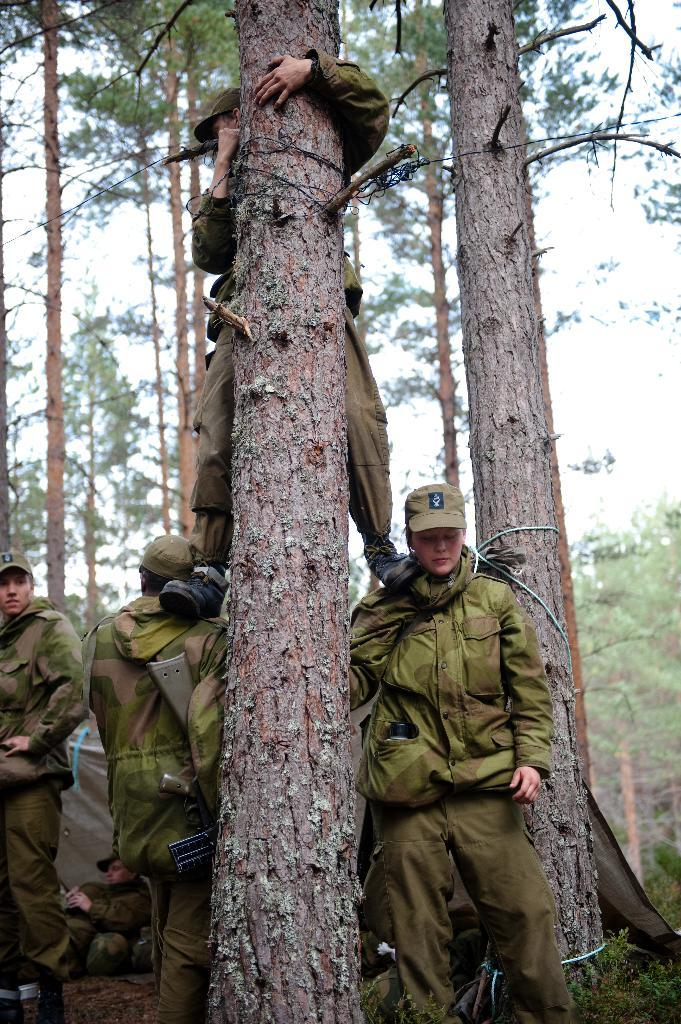What is the main subject of the image? The main subject of the image is a beautiful girl. What is the girl doing in the image? The girl is standing in the image. What type of clothing is the girl wearing? The girl is wearing a coat, a cap, and trousers in the image. Are there any other people in the image? Yes, there are men on the left side of the image. What else can be seen in the image besides the people? There are trees in the image, and a person is climbing a tree in the middle of the image. What type of railway can be seen in the image? There is no railway present in the image. What answer is the girl providing in the image? The image does not depict the girl providing an answer to any question or situation. 